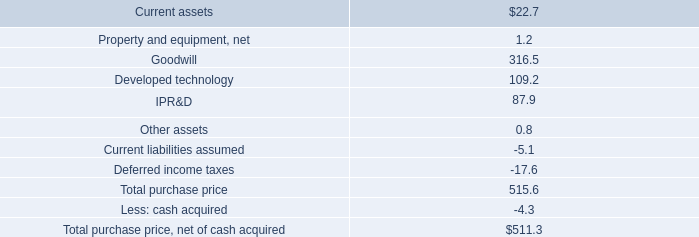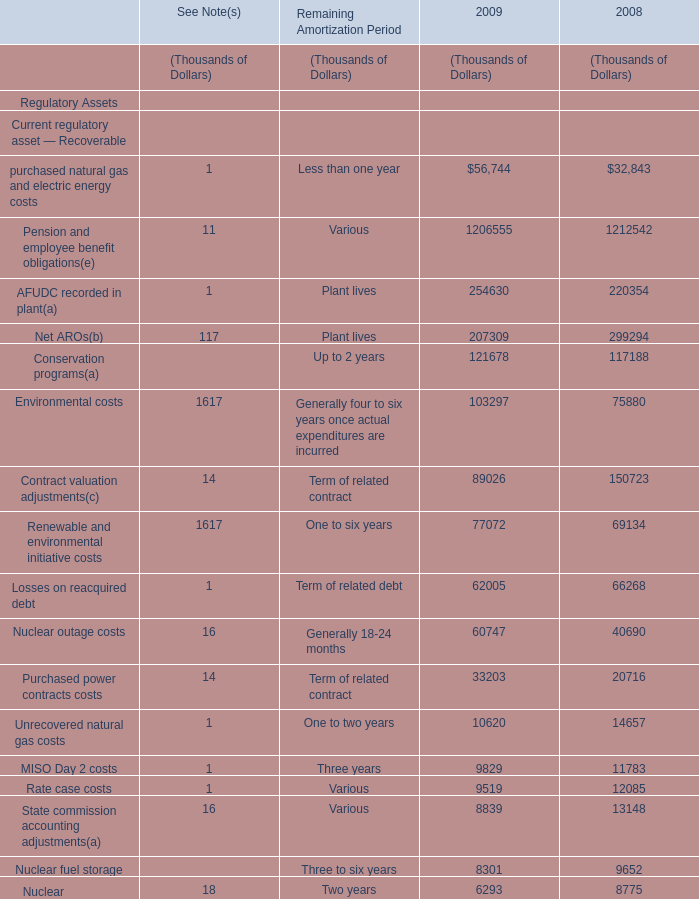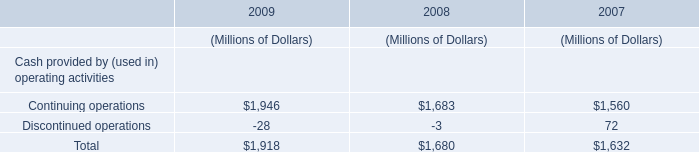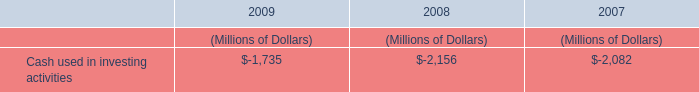what are the acquisition-related costs recorded in 201cselling , general , and administrative expenses 201d as a percentage of current assets? 
Computations: ((0.6 + 4.1) / 22.7)
Answer: 0.20705. 